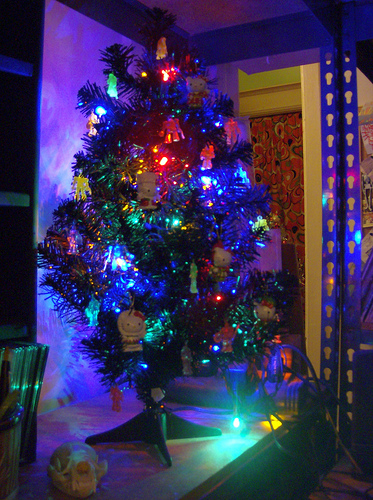<image>
Is there a christmas tree in front of the curtain? Yes. The christmas tree is positioned in front of the curtain, appearing closer to the camera viewpoint. 